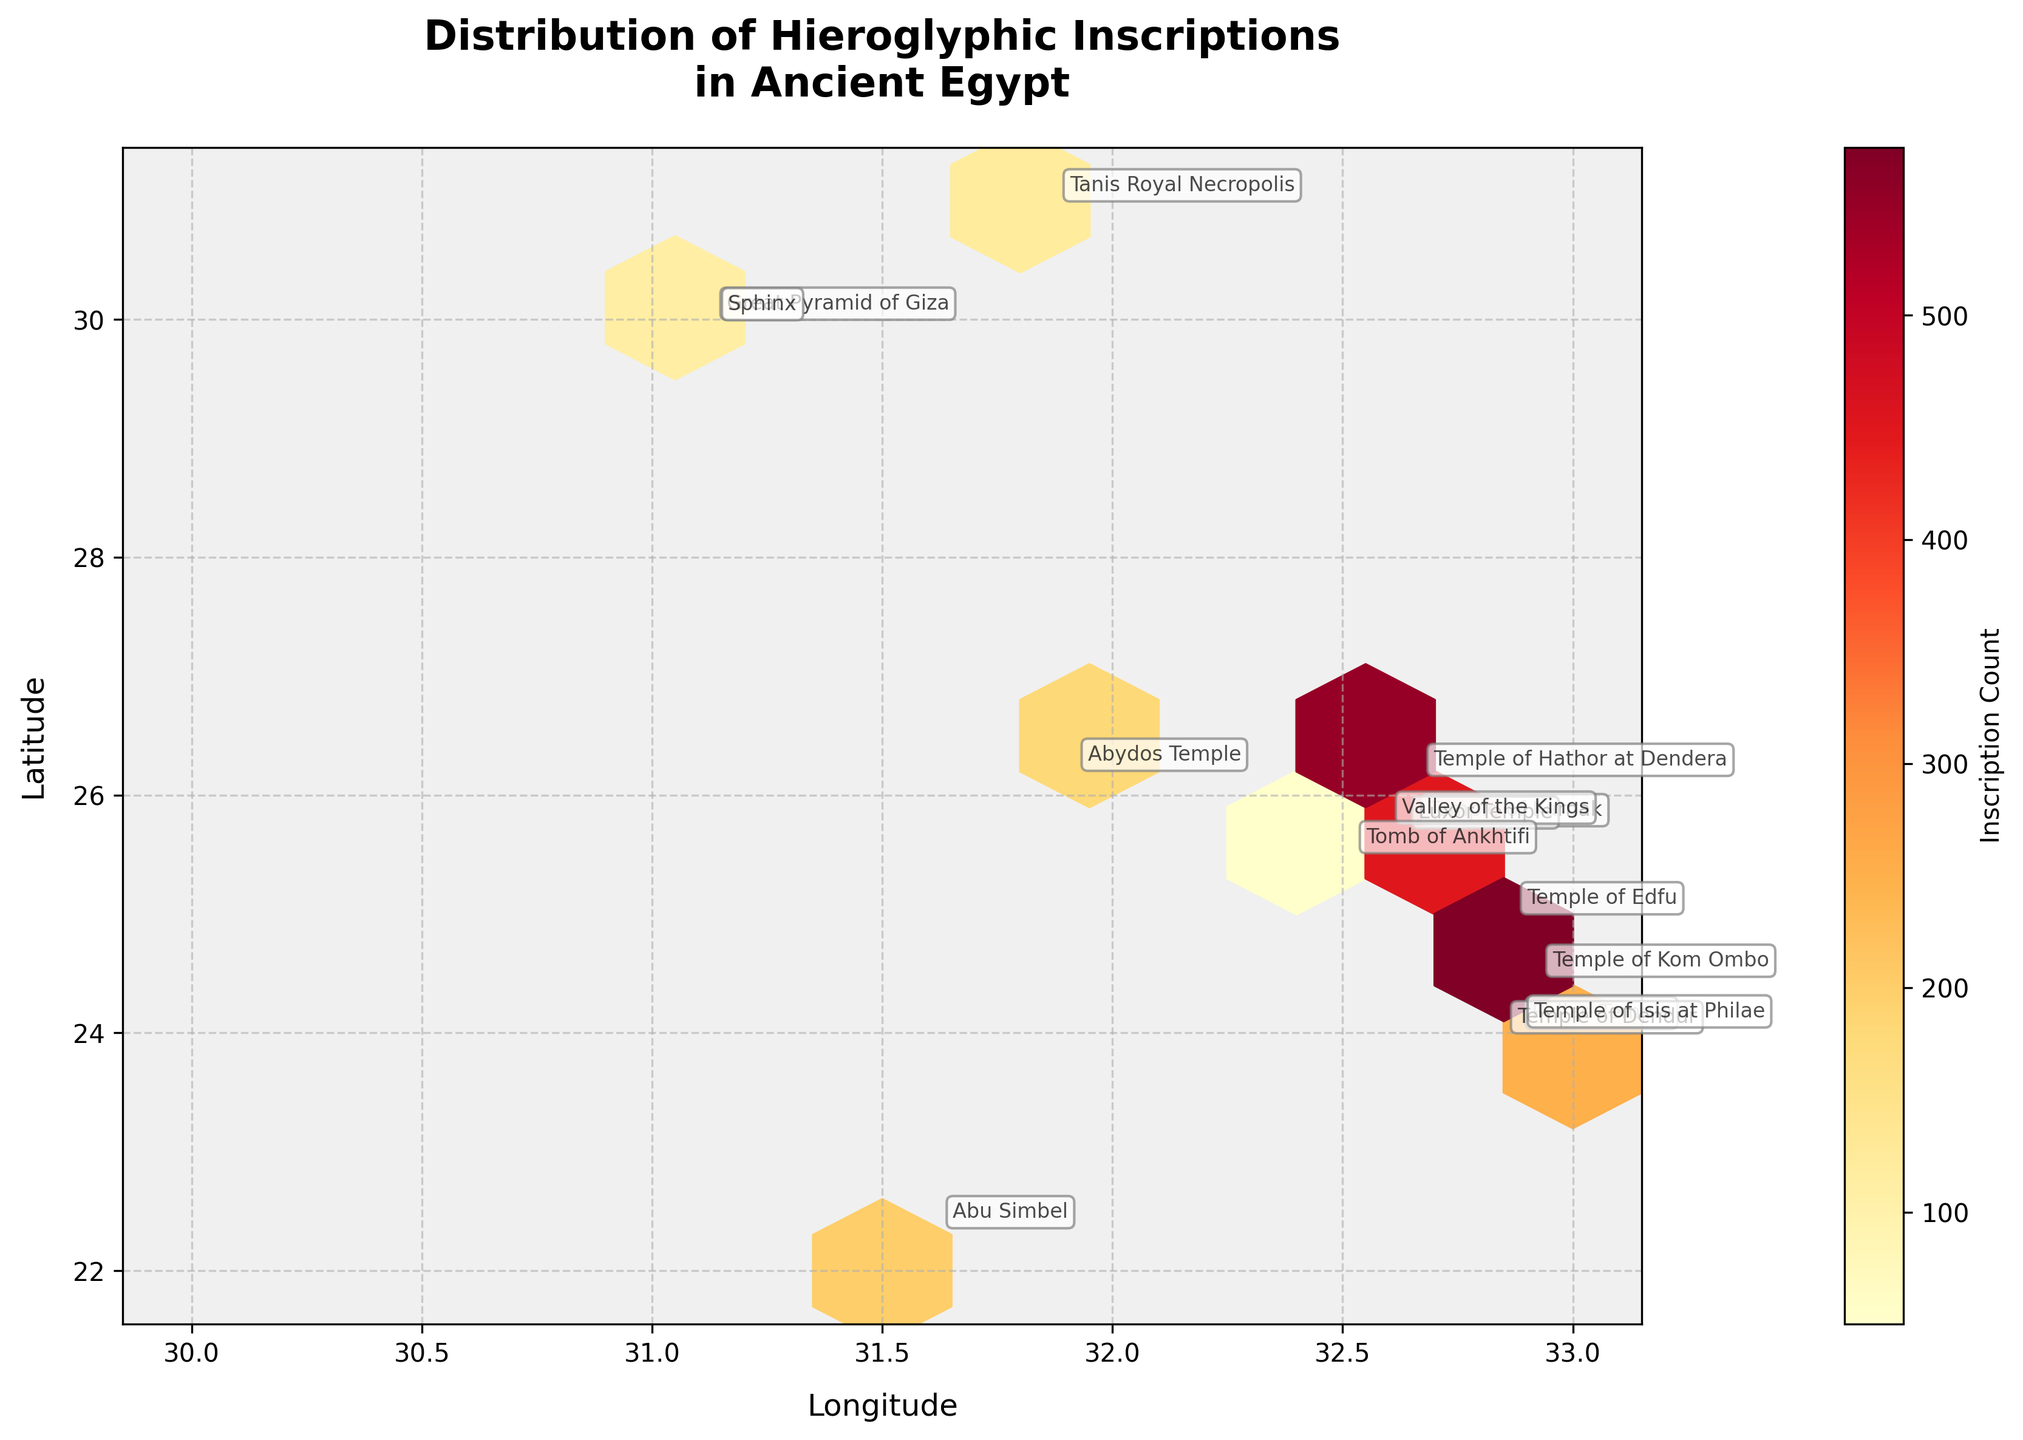What is the title of the figure? The title is located at the top center of the figure and is the largest text, usually indicating the subject of the plot.
Answer: Distribution of Hieroglyphic Inscriptions in Ancient Egypt How many monuments are depicted in the hexbin plot? To find this, we count the number of distinct monument annotations in the plot.
Answer: 15 Which area shows the highest concentration of hieroglyphic inscriptions? This can be determined by finding the region in the hexbin plot with the darkest color, as this represents a higher inscription count.
Answer: Near 25.7188 Latitude and 32.6572 Longitude (Temple of Karnak and Valley of the Kings area) What is the range of the total combined inscription counts in the New Kingdom monuments? By summing up the inscription counts for each monument in the New Kingdom category: Luxor Temple (450), Abu Simbel (200), and Valley of the Kings (600). Total = 450 + 200 + 600 = 1250.
Answer: 1250 Which monument in the Middle Kingdom has the highest number of inscriptions? By observing the annotations and the corresponding bin counts, we see the Temple of Karnak annotation is associated with the highest inscription count.
Answer: Temple of Karnak Compare the inscription counts of the Temple of Edfu and the Temple of Kom Ombo. Which has more? To answer this, we compare the numbers associated with each monument: Temple of Edfu (800) versus Temple of Kom Ombo (350).
Answer: Temple of Edfu What can be inferred about the location of Ptolemaic period monuments relative to their inscriptions? By analyzing the plot for regions where Ptolemaic monuments are annotated (Temple of Edfu and Temple of Kom Ombo), we observe that these locations have high inscription counts.
Answer: Ptolemaic monuments are in areas with high inscription counts How does the inscription count at the Temple of Hathor at Dendera compare to those of other Greco-Roman monuments? We find the Temple of Hathor at Dendera has an inscription count of 550, while the other Greco-Roman monument, Temple of Isis at Philae, has a count of 400.
Answer: Temple of Hathor at Dendera has more inscriptions What relationship can be seen in the distribution of inscriptions and the latitude of the New Kingdom monuments? By examining the hexbin plot for latitude trends, we observe New Kingdom monuments (Luxor Temple, Abu Simbel, Valley of the Kings) cluster around specific latitudes with higher inscription counts.
Answer: New Kingdom monuments have high inscription counts around Latitude 25-26 Which dynasty's monuments are primarily located in the northernmost regions of the plot? By identifying the annotations in the upper (northern) region of the plot, we see the Old Kingdom monuments (Great Pyramid of Giza and Sphinx) are situated there.
Answer: Old Kingdom 